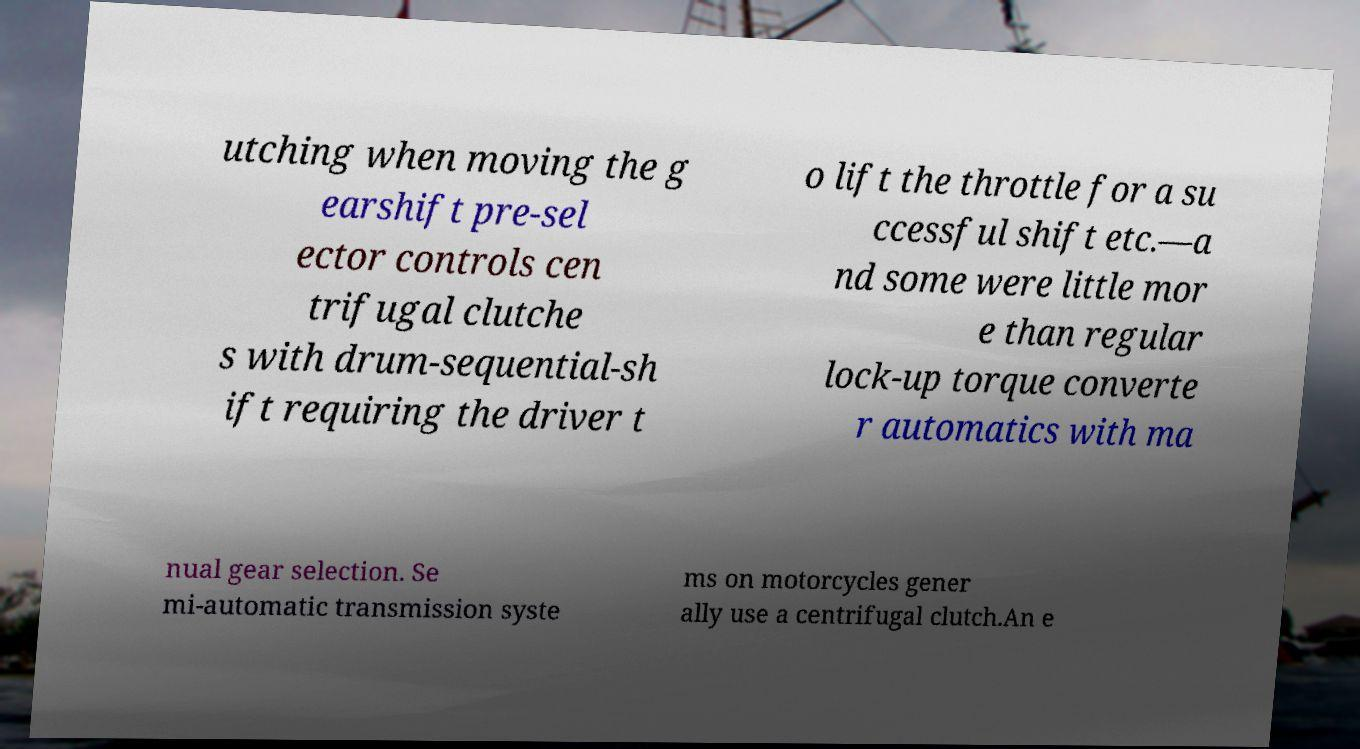What messages or text are displayed in this image? I need them in a readable, typed format. utching when moving the g earshift pre-sel ector controls cen trifugal clutche s with drum-sequential-sh ift requiring the driver t o lift the throttle for a su ccessful shift etc.—a nd some were little mor e than regular lock-up torque converte r automatics with ma nual gear selection. Se mi-automatic transmission syste ms on motorcycles gener ally use a centrifugal clutch.An e 